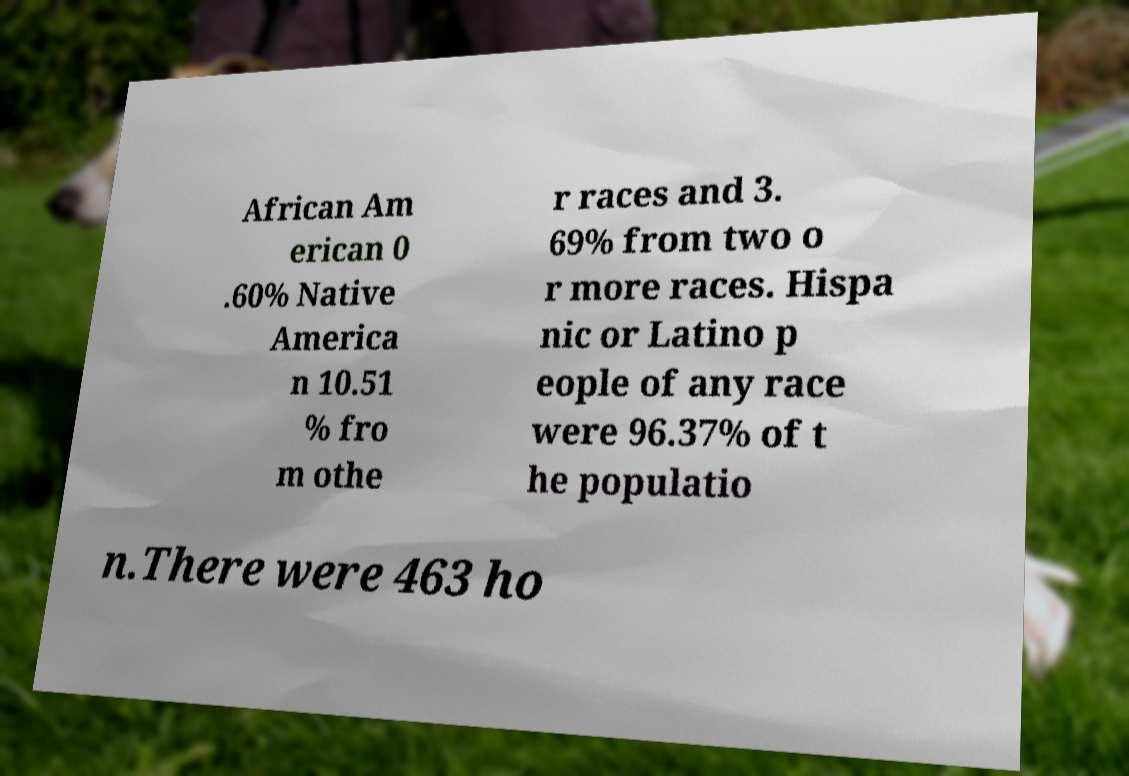Could you extract and type out the text from this image? African Am erican 0 .60% Native America n 10.51 % fro m othe r races and 3. 69% from two o r more races. Hispa nic or Latino p eople of any race were 96.37% of t he populatio n.There were 463 ho 